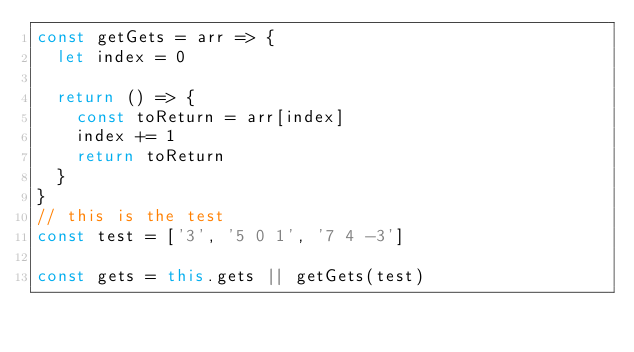<code> <loc_0><loc_0><loc_500><loc_500><_JavaScript_>const getGets = arr => {
  let index = 0

  return () => {
    const toReturn = arr[index]
    index += 1
    return toReturn
  }
}
// this is the test
const test = ['3', '5 0 1', '7 4 -3']

const gets = this.gets || getGets(test)</code> 